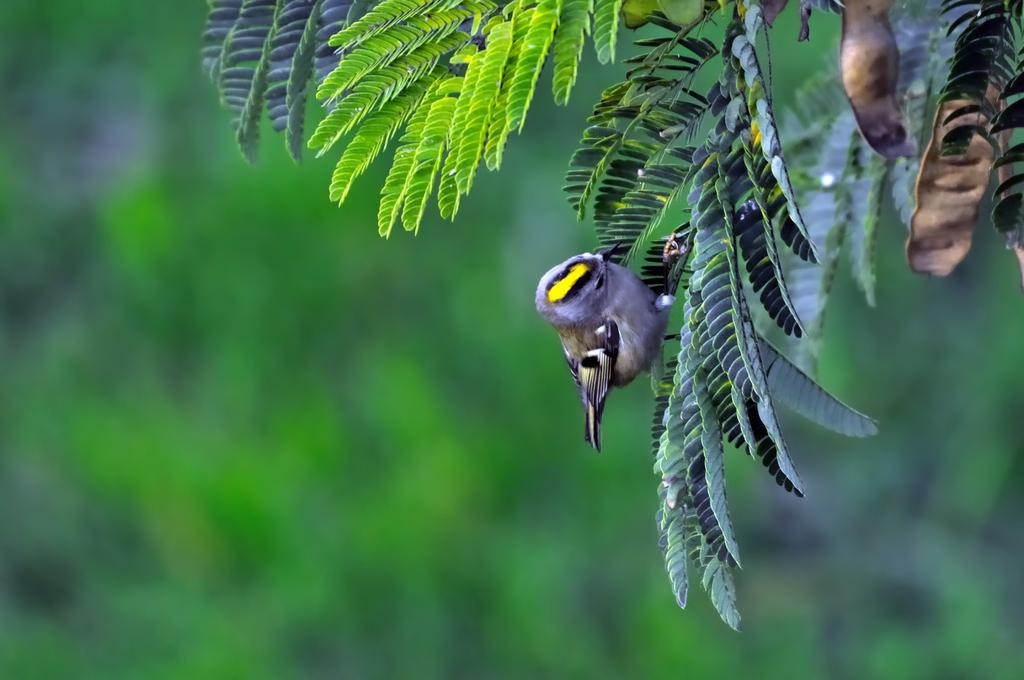What type of animal is in the image? There is a bird in the image. Where is the bird located in the image? The bird is on the right side of the image. What is the bird standing on in the image? The bird is on leaves in the image. What type of line is visible in the middle of the image? There is no line visible in the middle of the image. 